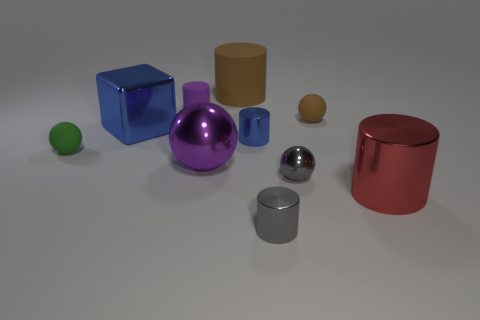Subtract all brown matte cylinders. How many cylinders are left? 4 Subtract all gray cylinders. How many cylinders are left? 4 Subtract all cyan cylinders. Subtract all purple spheres. How many cylinders are left? 5 Subtract all balls. How many objects are left? 6 Add 2 tiny purple rubber objects. How many tiny purple rubber objects are left? 3 Add 4 big red things. How many big red things exist? 5 Subtract 1 green balls. How many objects are left? 9 Subtract all green cylinders. Subtract all big brown rubber cylinders. How many objects are left? 9 